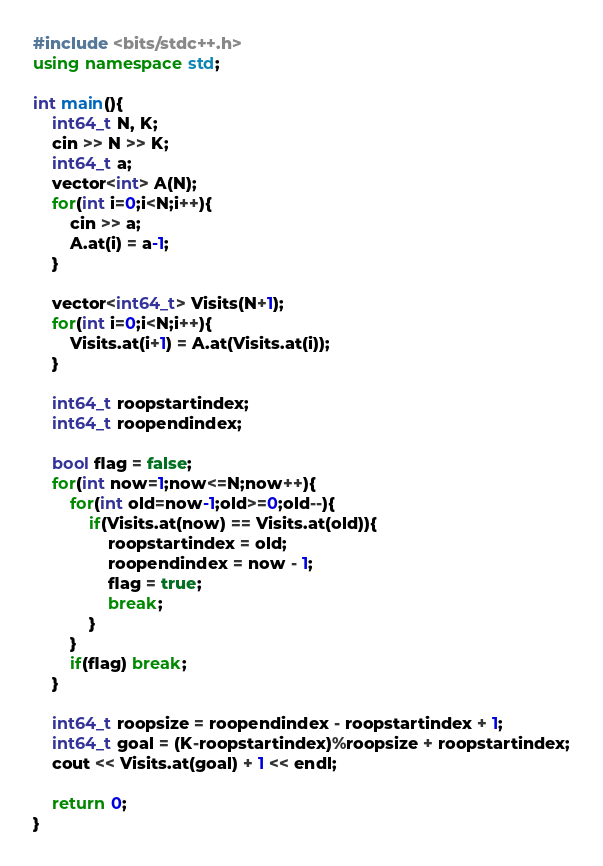<code> <loc_0><loc_0><loc_500><loc_500><_C++_>#include <bits/stdc++.h>
using namespace std;

int main(){
	int64_t N, K;
	cin >> N >> K;
	int64_t a;
	vector<int> A(N);
	for(int i=0;i<N;i++){
		cin >> a;
		A.at(i) = a-1;
	}

	vector<int64_t> Visits(N+1);
	for(int i=0;i<N;i++){
		Visits.at(i+1) = A.at(Visits.at(i));
	}
  
	int64_t roopstartindex;
  	int64_t roopendindex;
  	
	bool flag = false;
	for(int now=1;now<=N;now++){
		for(int old=now-1;old>=0;old--){
			if(Visits.at(now) == Visits.at(old)){
				roopstartindex = old;
				roopendindex = now - 1;
  				flag = true;
				break;
			}
		}
		if(flag) break;
	}
  
	int64_t roopsize = roopendindex - roopstartindex + 1;
	int64_t goal = (K-roopstartindex)%roopsize + roopstartindex;
	cout << Visits.at(goal) + 1 << endl;

	return 0;
}</code> 